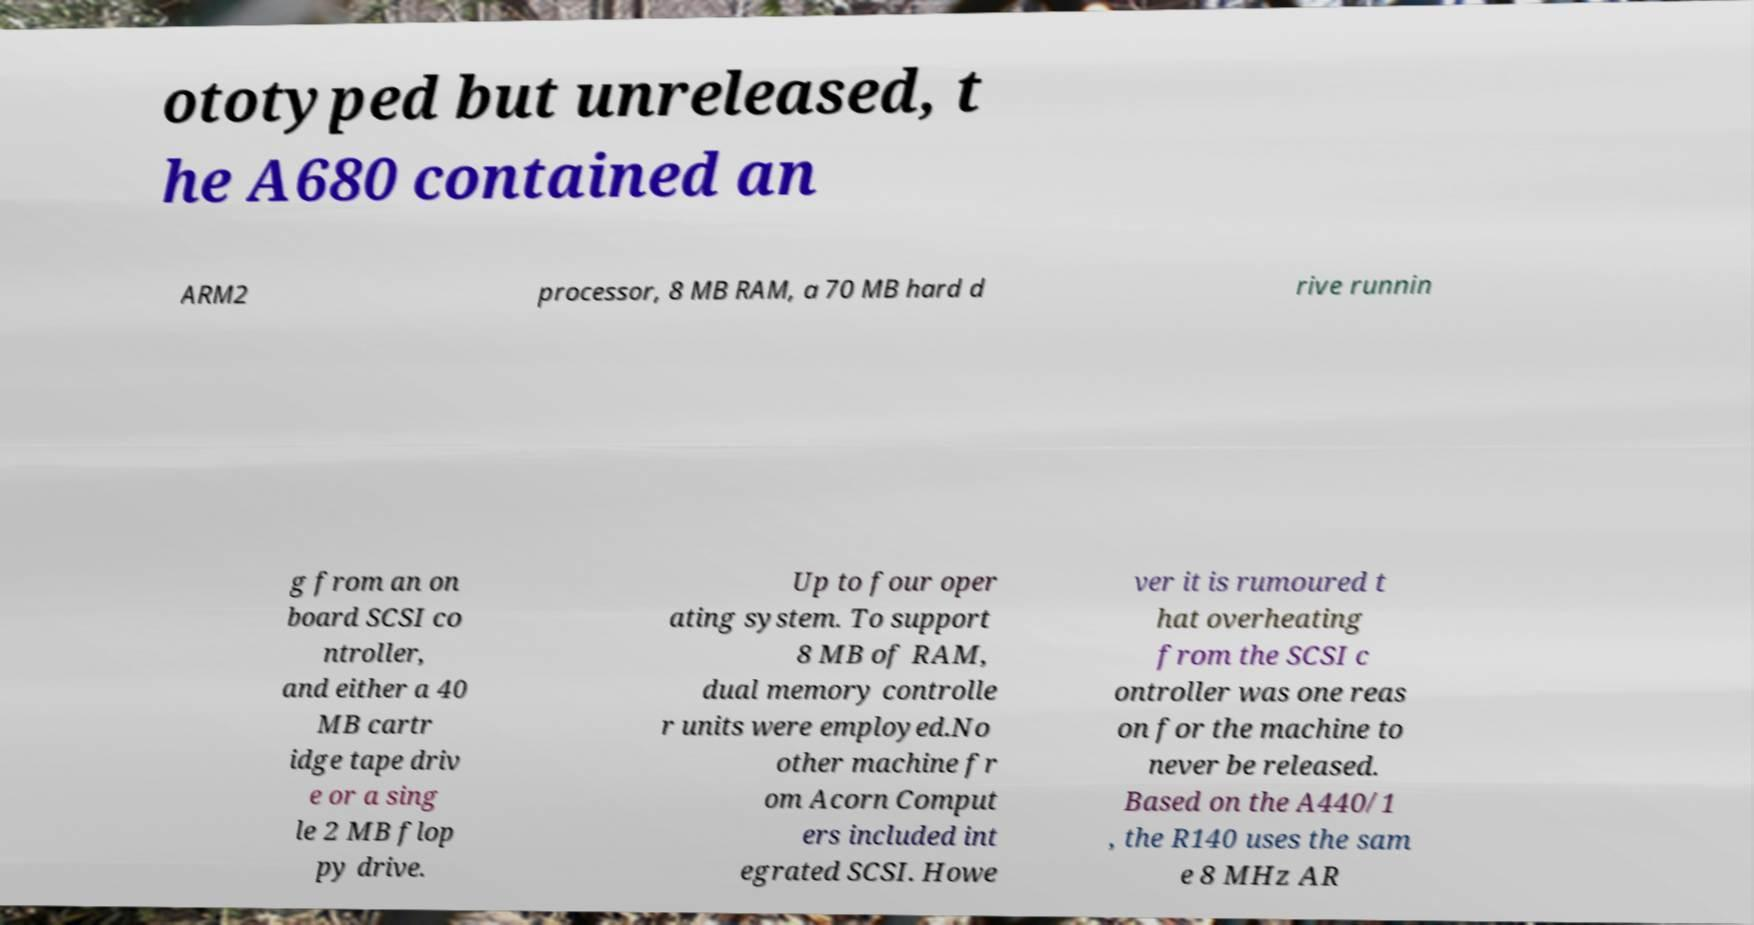Could you assist in decoding the text presented in this image and type it out clearly? ototyped but unreleased, t he A680 contained an ARM2 processor, 8 MB RAM, a 70 MB hard d rive runnin g from an on board SCSI co ntroller, and either a 40 MB cartr idge tape driv e or a sing le 2 MB flop py drive. Up to four oper ating system. To support 8 MB of RAM, dual memory controlle r units were employed.No other machine fr om Acorn Comput ers included int egrated SCSI. Howe ver it is rumoured t hat overheating from the SCSI c ontroller was one reas on for the machine to never be released. Based on the A440/1 , the R140 uses the sam e 8 MHz AR 